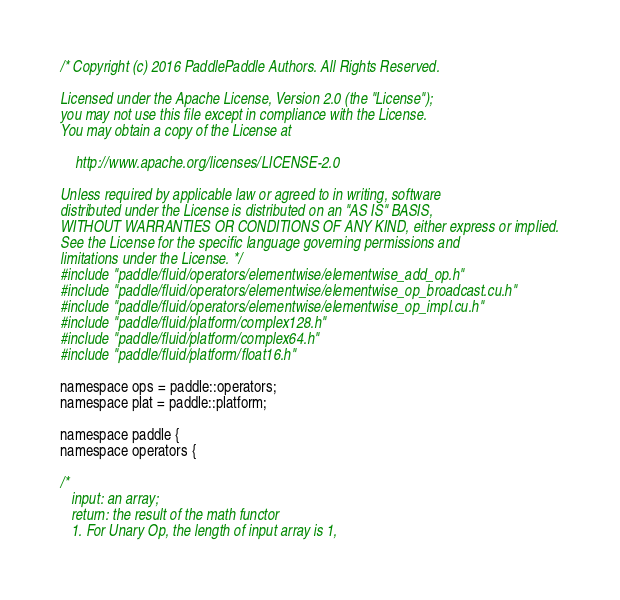Convert code to text. <code><loc_0><loc_0><loc_500><loc_500><_Cuda_>/* Copyright (c) 2016 PaddlePaddle Authors. All Rights Reserved.

Licensed under the Apache License, Version 2.0 (the "License");
you may not use this file except in compliance with the License.
You may obtain a copy of the License at

    http://www.apache.org/licenses/LICENSE-2.0

Unless required by applicable law or agreed to in writing, software
distributed under the License is distributed on an "AS IS" BASIS,
WITHOUT WARRANTIES OR CONDITIONS OF ANY KIND, either express or implied.
See the License for the specific language governing permissions and
limitations under the License. */
#include "paddle/fluid/operators/elementwise/elementwise_add_op.h"
#include "paddle/fluid/operators/elementwise/elementwise_op_broadcast.cu.h"
#include "paddle/fluid/operators/elementwise/elementwise_op_impl.cu.h"
#include "paddle/fluid/platform/complex128.h"
#include "paddle/fluid/platform/complex64.h"
#include "paddle/fluid/platform/float16.h"

namespace ops = paddle::operators;
namespace plat = paddle::platform;

namespace paddle {
namespace operators {

/*
   input: an array;
   return: the result of the math functor
   1. For Unary Op, the length of input array is 1,</code> 